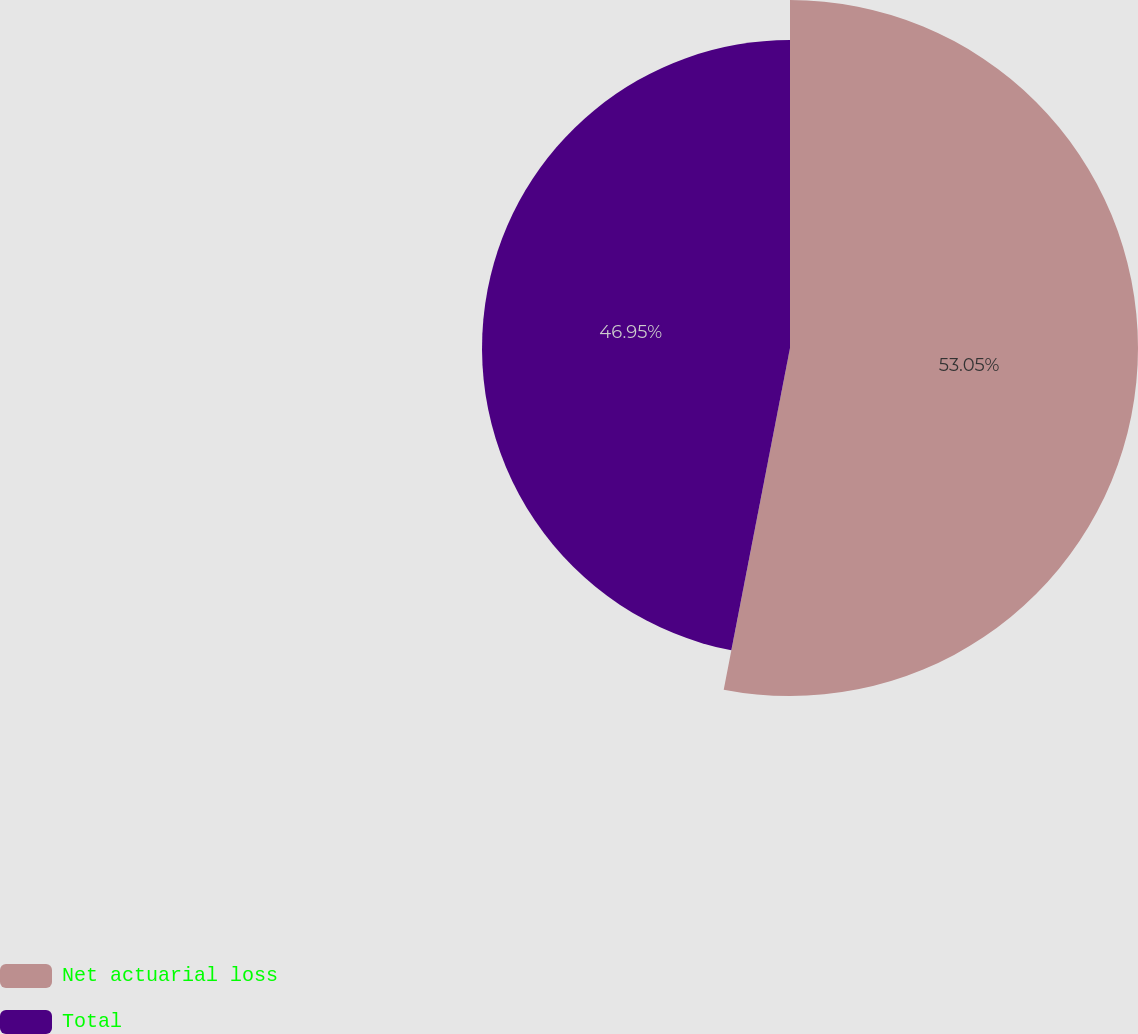Convert chart to OTSL. <chart><loc_0><loc_0><loc_500><loc_500><pie_chart><fcel>Net actuarial loss<fcel>Total<nl><fcel>53.05%<fcel>46.95%<nl></chart> 